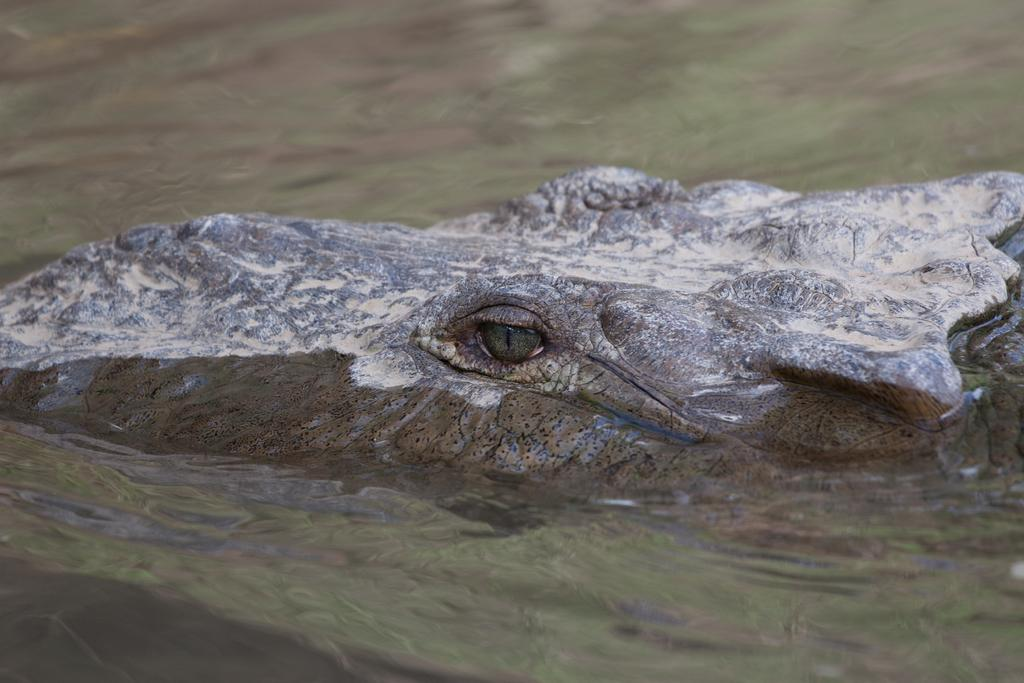What is the main subject of the image? There is an animal in the water in the image. Can you describe the animal's location in the image? The animal is in the water. What type of environment is depicted in the image? The image shows a water environment. What type of event is taking place in the image? There is no event taking place in the image; it simply shows an animal in the water. Can you tell me how the animal is producing energy in the image? There is no indication of energy production in the image; it only shows an animal in the water. 